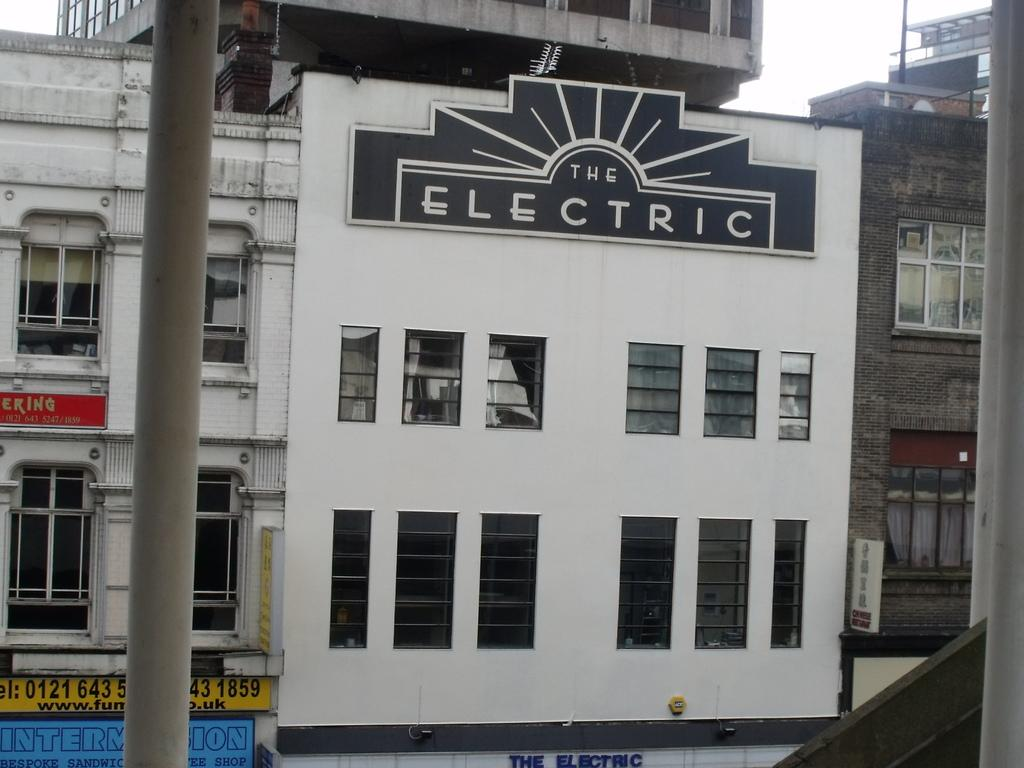What type of structures are present in the image? There are buildings in the image. What feature can be seen on the buildings? The buildings have windows. What is visible at the top of the image? The sky is visible at the top of the image. What object is located on the left side of the image? There is a pole on the left side of the image. What type of insect can be seen playing in the band on the street in the image? There is no insect, band, or street present in the image. 